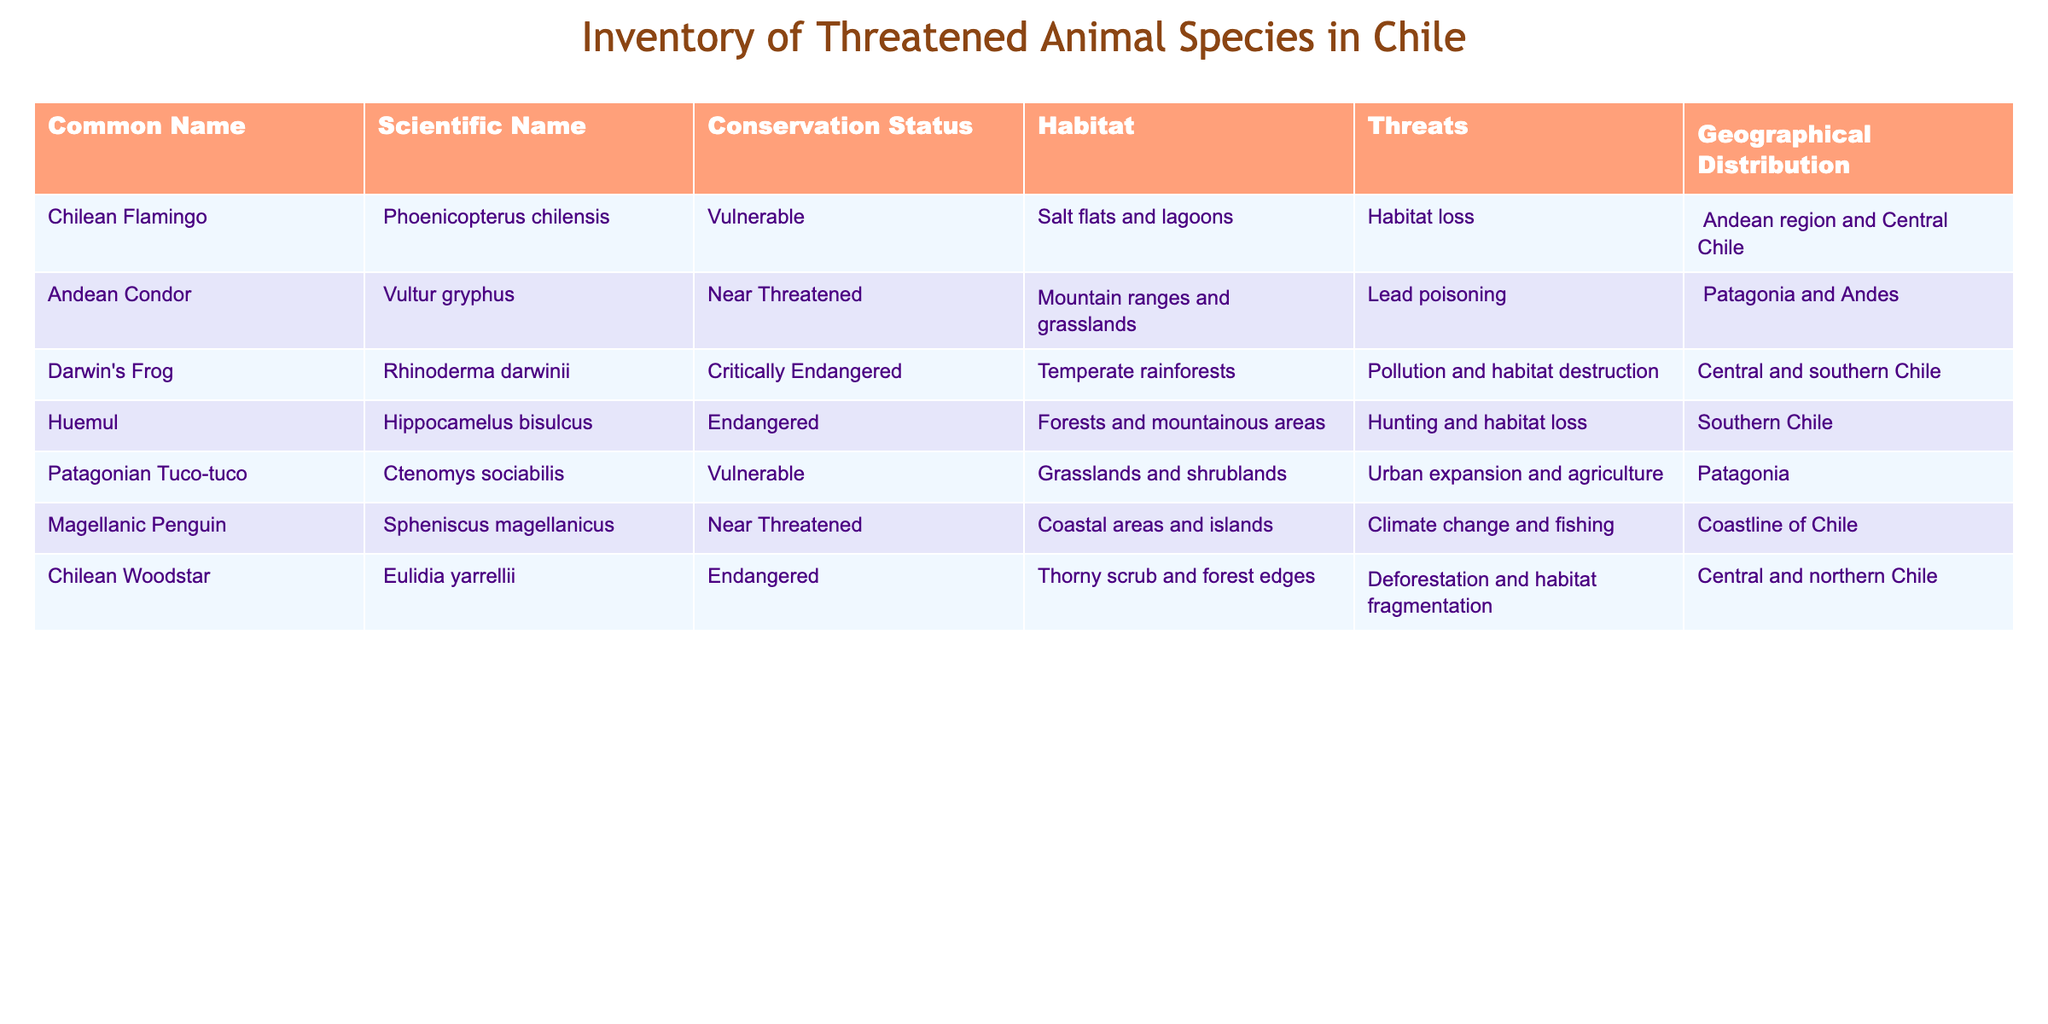What is the conservation status of the Chilean Flamingo? The table lists the Chilean Flamingo under the "Conservation Status" column, where it is indicated as 'Vulnerable'.
Answer: Vulnerable Which species are classified as Endangered? The "Conservation Status" column shows that two species are classified as Endangered: the Huemul and the Chilean Woodstar.
Answer: Huemul and Chilean Woodstar Does the Magellanic Penguin face threats from climate change? The "Threats" column for the Magellanic Penguin states 'Climate change and fishing', which confirms that it does face threats from climate change.
Answer: Yes How many species are classified as Near Threatened? By checking the "Conservation Status" column, there are two species—Andean Condor and Magellanic Penguin—that are classified as Near Threatened.
Answer: 2 Which habitat is designated for Darwin's Frog? In the "Habitat" column, Darwin's Frog is associated with 'Temperate rainforests', directly indicating its natural habitat.
Answer: Temperate rainforests What is the total number of species listed in the table that are either Vulnerable or Endangered? There are three species labeled as Vulnerable (Chilean Flamingo, Patagonian Tuco-tuco) and three species labeled as Endangered (Huemul, Chilean Woodstar). Adding these gives 3 + 3 = 6 species in total.
Answer: 6 Are all listed species found only in Southern Chile? The geographical distribution indicates that several species, such as the Chilean Flamingo and the Magellanic Penguin, are found in different regions of Chile, not limited to the south.
Answer: No What is the primary threat to the Huemul? The "Threats" column identifies 'Hunting and habitat loss' as the primary threat to the Huemul.
Answer: Hunting and habitat loss Which species can be found in Central and Northern Chile? By examining the geographical distribution, the Chilean Woodstar and the Chilean Flamingo are the species that can be found in Central and Northern Chile.
Answer: Chilean Woodstar and Chilean Flamingo 